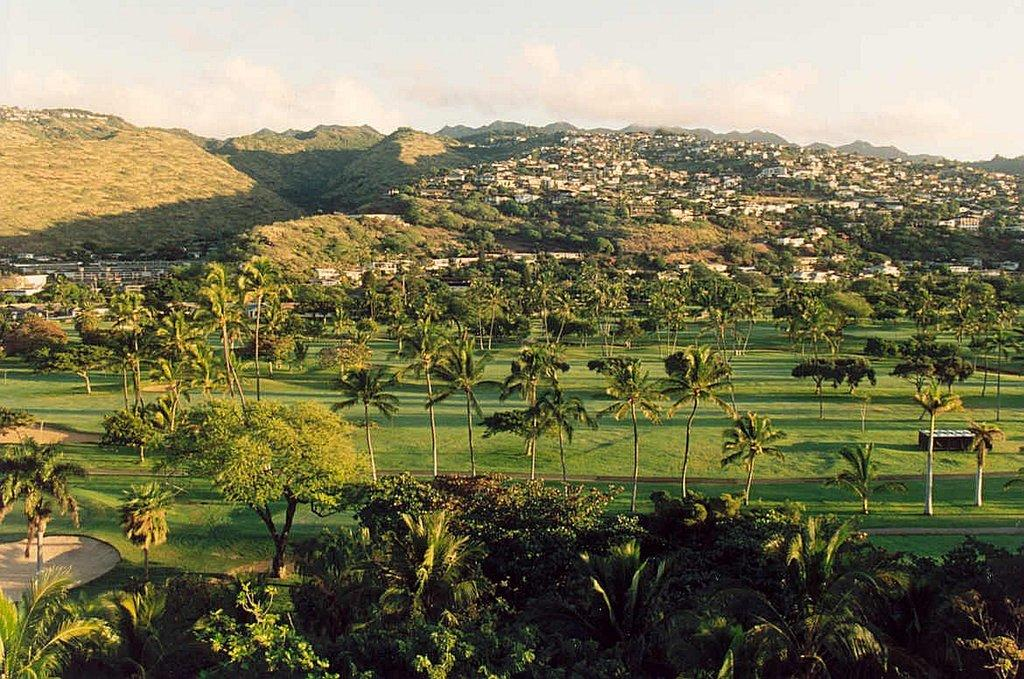What type of vegetation is present in the image? There are many trees in the image. What structures can be seen in the background of the image? There are houses and mountains in the background of the image. What else can be seen in the background of the image? There are clouds and the sky visible in the background of the image. What type of rice is being cooked in the image? There is no rice present in the image. What type of apparel are the trees wearing in the image? Trees do not wear apparel, as they are plants and not people. 